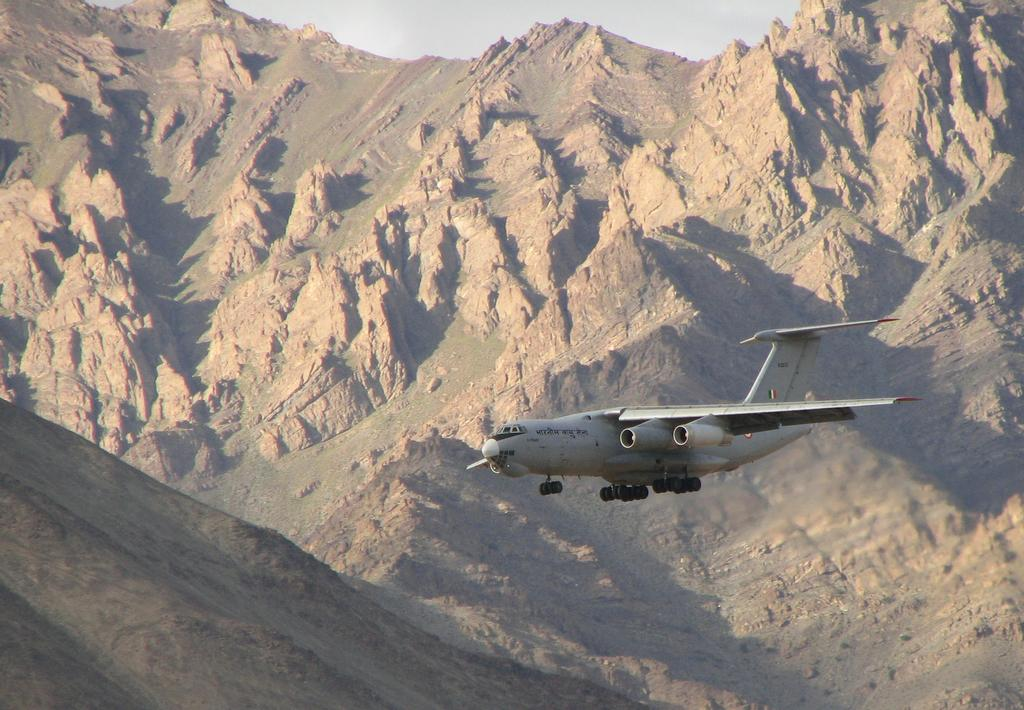What is the main subject of the image? The main subject of the image is an aeroplane. Where is the aeroplane located in the image? The aeroplane is in the middle of the image. What can be seen in the background of the image? There are hills in the background of the image. What is visible at the top of the image? The sky is visible at the top of the image. How many legs does the aeroplane have in the image? Airplanes do not have legs; they have wheels for landing and taking off. In the image, the aeroplane does not have any visible legs or wheels. 